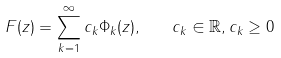<formula> <loc_0><loc_0><loc_500><loc_500>F ( z ) = \sum _ { k = 1 } ^ { \infty } c _ { k } \Phi _ { k } ( z ) , \quad c _ { k } \in \mathbb { R } , c _ { k } \geq 0</formula> 